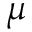<formula> <loc_0><loc_0><loc_500><loc_500>\mu</formula> 